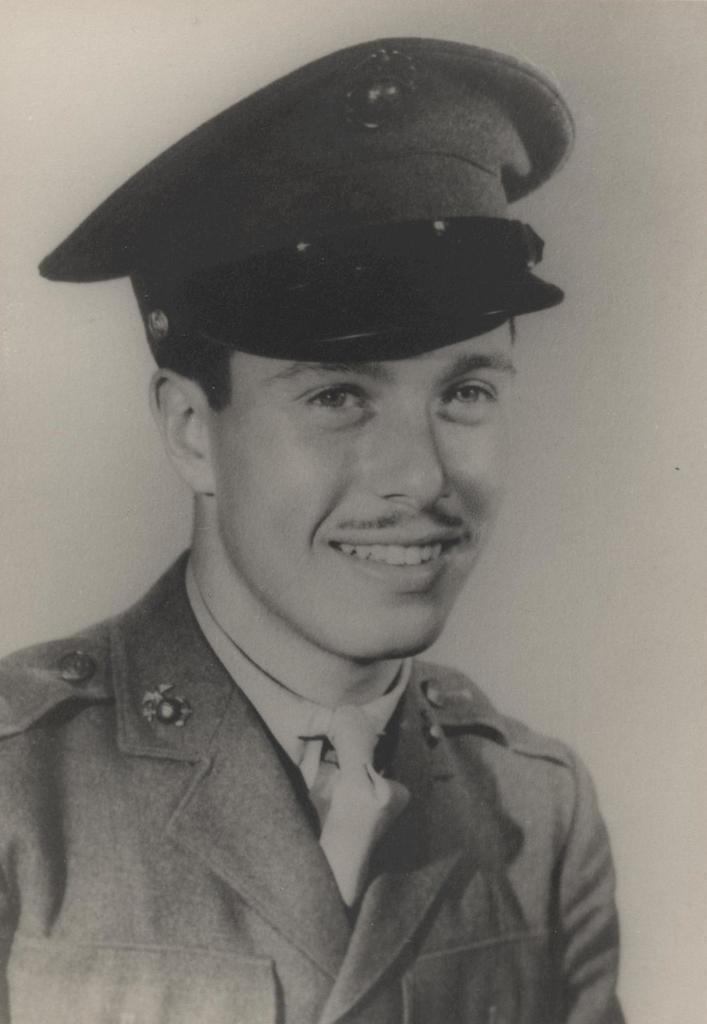Describe this image in one or two sentences. This is a black and white picture and in this picture we can see a man wore a cap and smiling. 